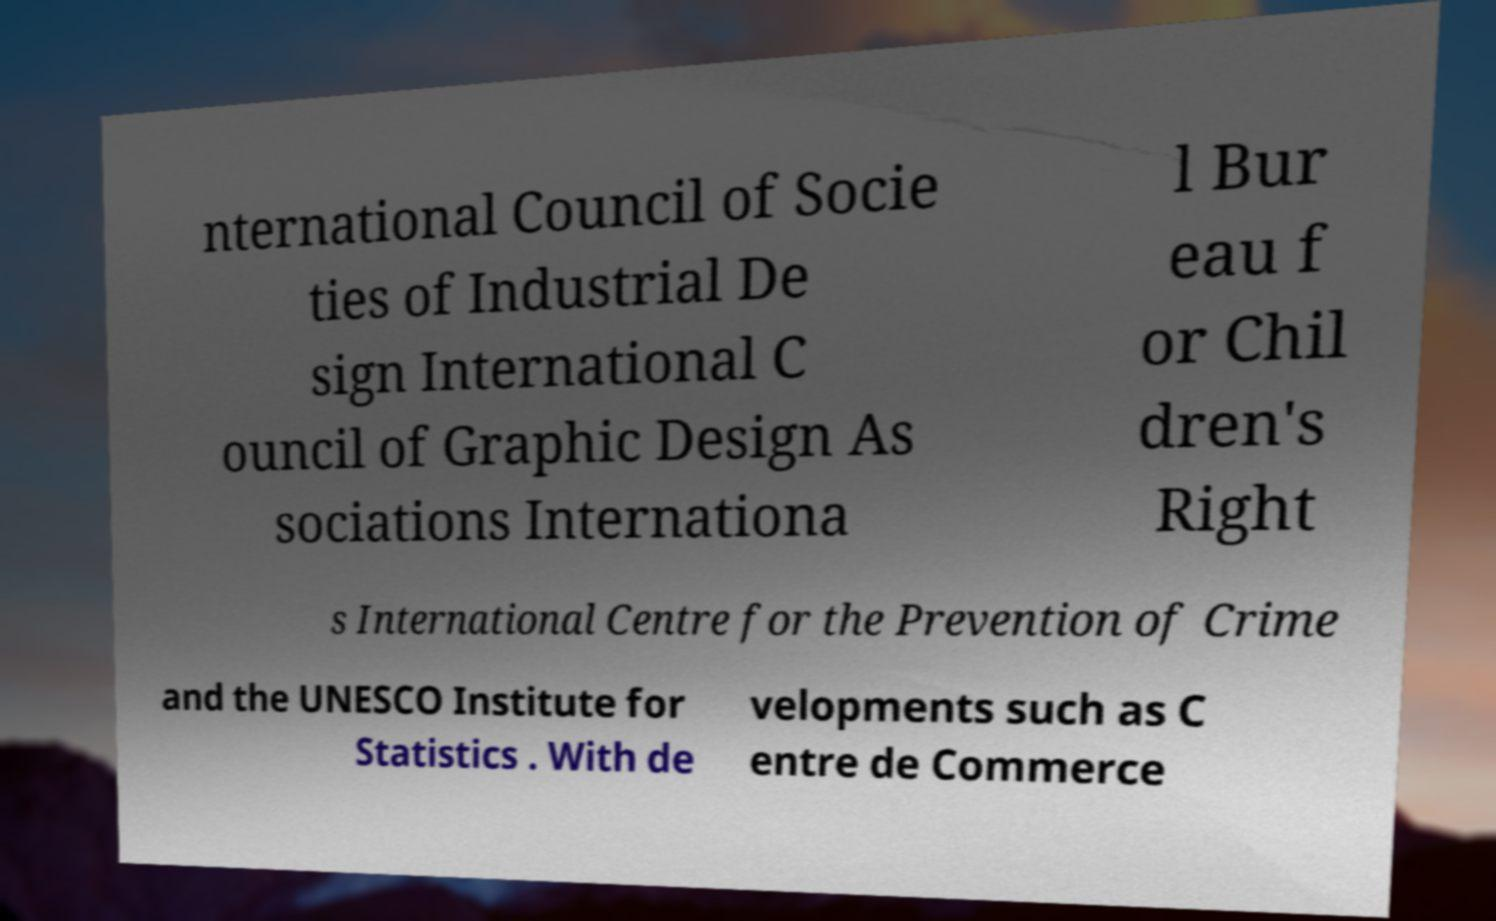For documentation purposes, I need the text within this image transcribed. Could you provide that? nternational Council of Socie ties of Industrial De sign International C ouncil of Graphic Design As sociations Internationa l Bur eau f or Chil dren's Right s International Centre for the Prevention of Crime and the UNESCO Institute for Statistics . With de velopments such as C entre de Commerce 